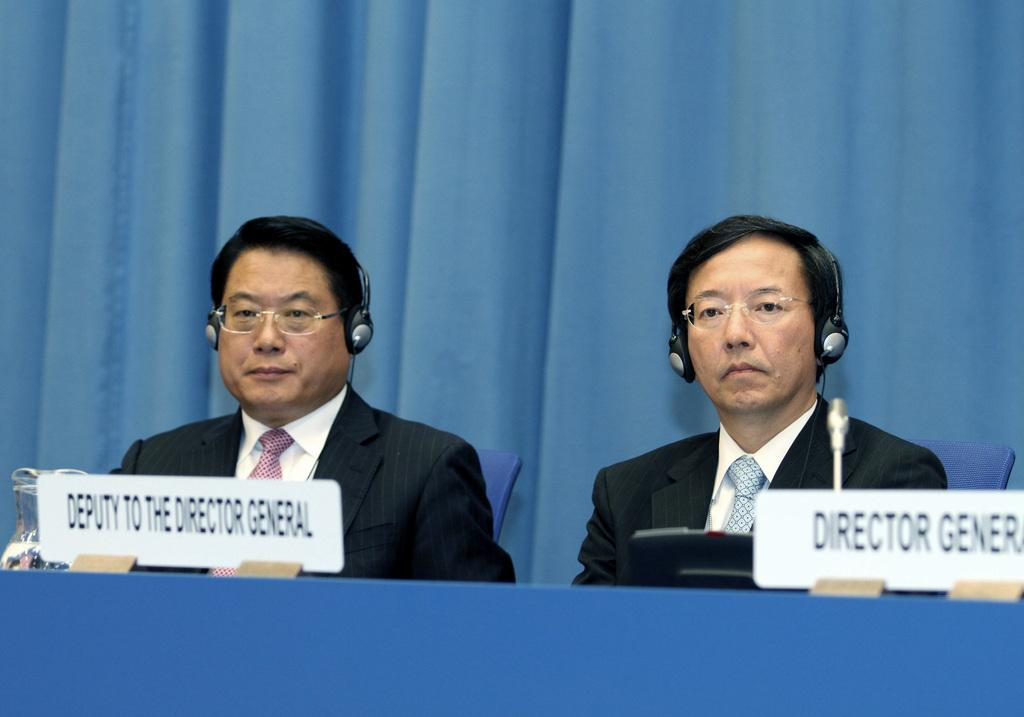<image>
Give a short and clear explanation of the subsequent image. Two men with headphones with signs, one labeled Deputy to the Director General. 